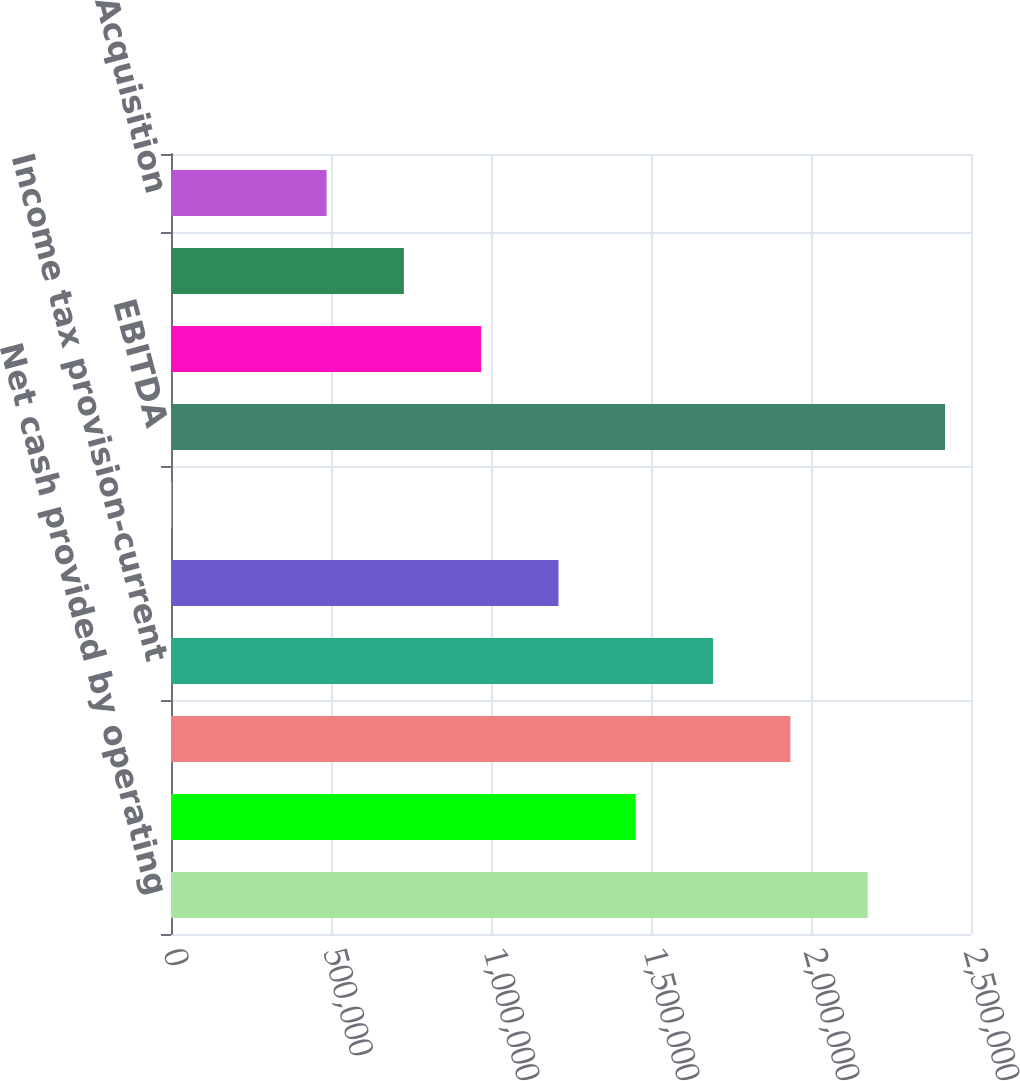Convert chart to OTSL. <chart><loc_0><loc_0><loc_500><loc_500><bar_chart><fcel>Net cash provided by operating<fcel>Changes in assets and<fcel>Interest expense net (1)<fcel>Income tax provision-current<fcel>Stock compensation expense (3)<fcel>Refinancing costs (4)<fcel>EBITDA<fcel>Inventory purchase accounting<fcel>Acquisition integration costs<fcel>Acquisition<nl><fcel>2.17722e+06<fcel>1.45249e+06<fcel>1.93564e+06<fcel>1.69406e+06<fcel>1.21091e+06<fcel>3013<fcel>2.4188e+06<fcel>969328<fcel>727749<fcel>486171<nl></chart> 